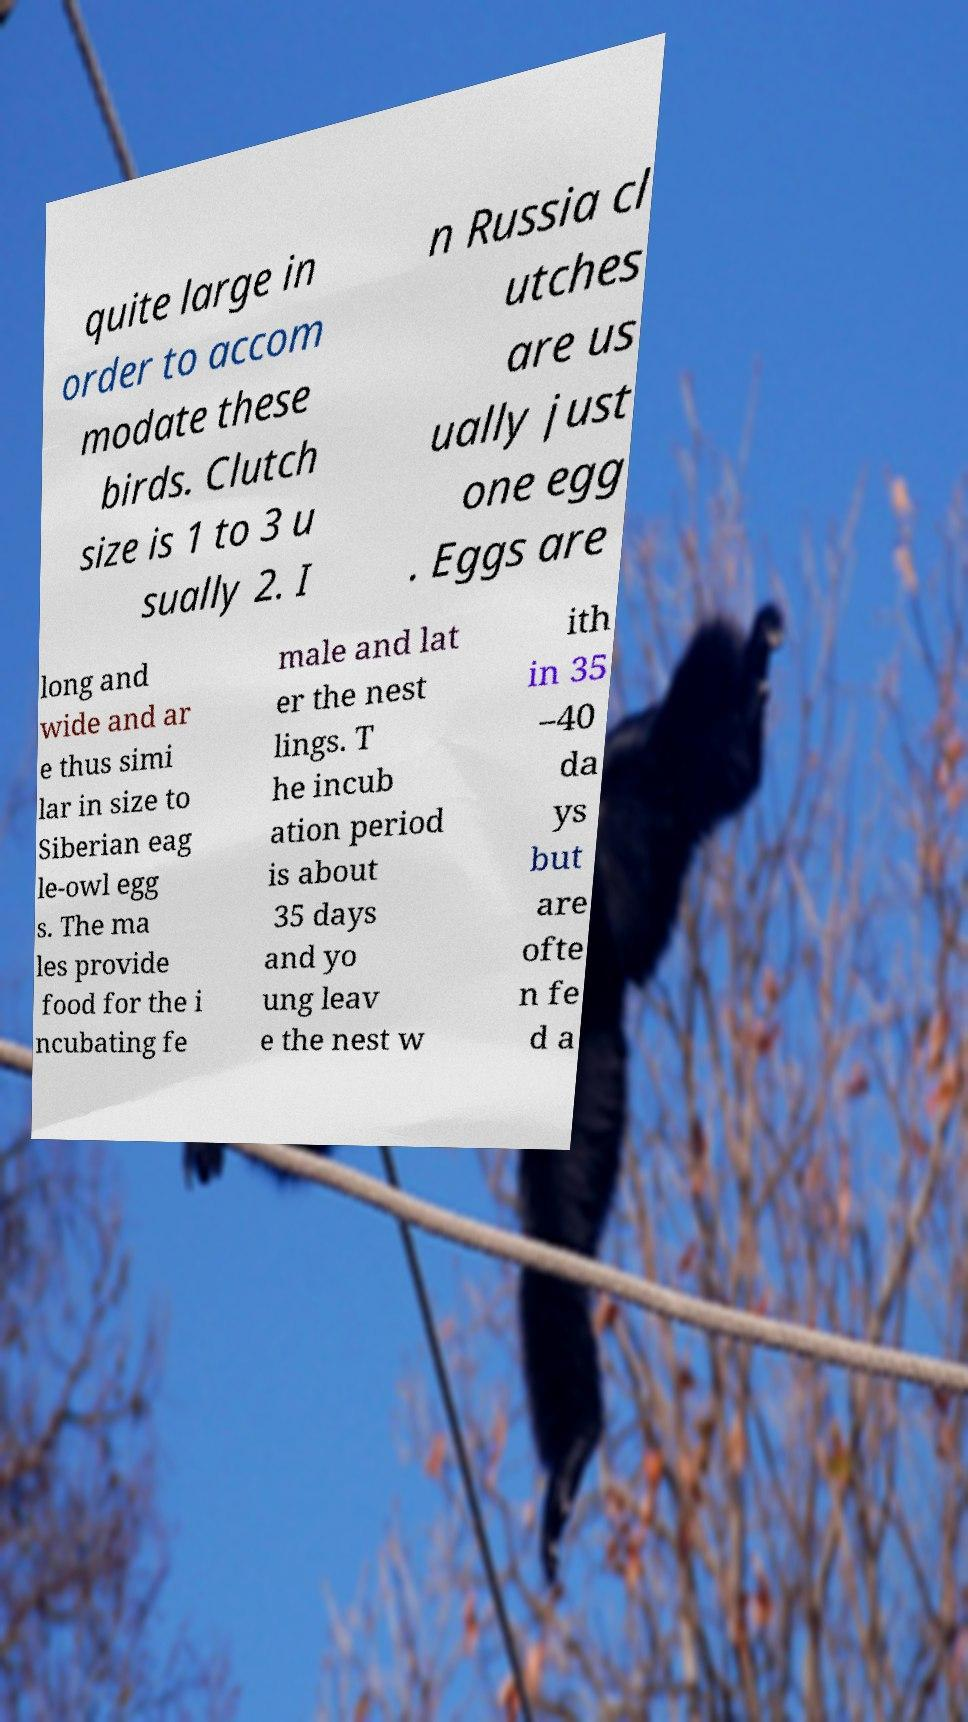There's text embedded in this image that I need extracted. Can you transcribe it verbatim? quite large in order to accom modate these birds. Clutch size is 1 to 3 u sually 2. I n Russia cl utches are us ually just one egg . Eggs are long and wide and ar e thus simi lar in size to Siberian eag le-owl egg s. The ma les provide food for the i ncubating fe male and lat er the nest lings. T he incub ation period is about 35 days and yo ung leav e the nest w ith in 35 –40 da ys but are ofte n fe d a 